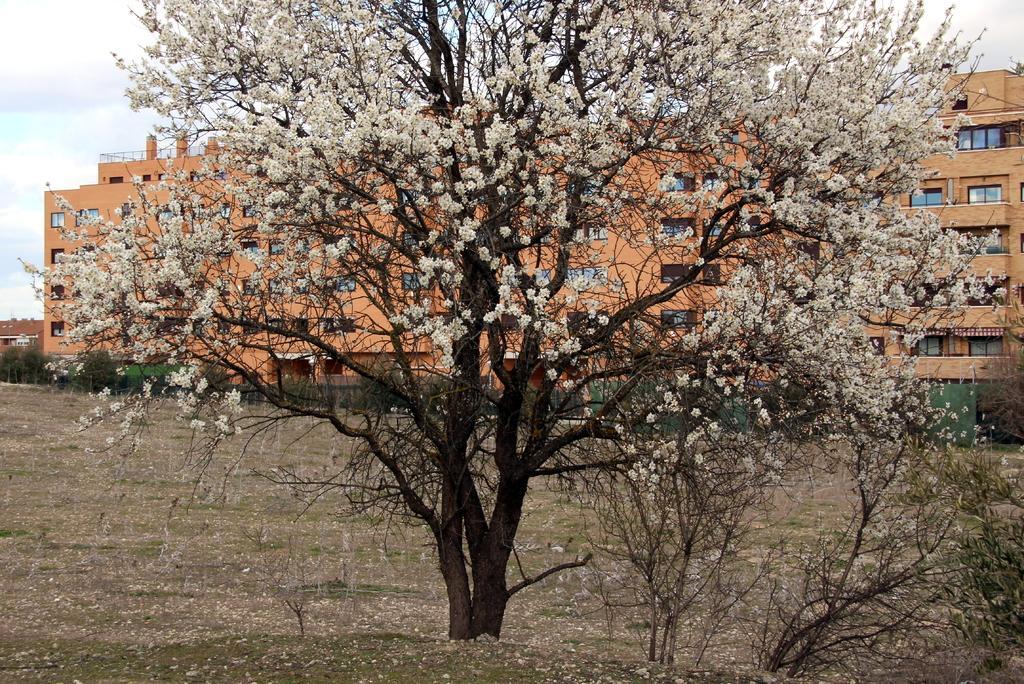In one or two sentences, can you explain what this image depicts? In this image we can see trees, flowers, ground, and buildings. In the background there is sky with clouds. 